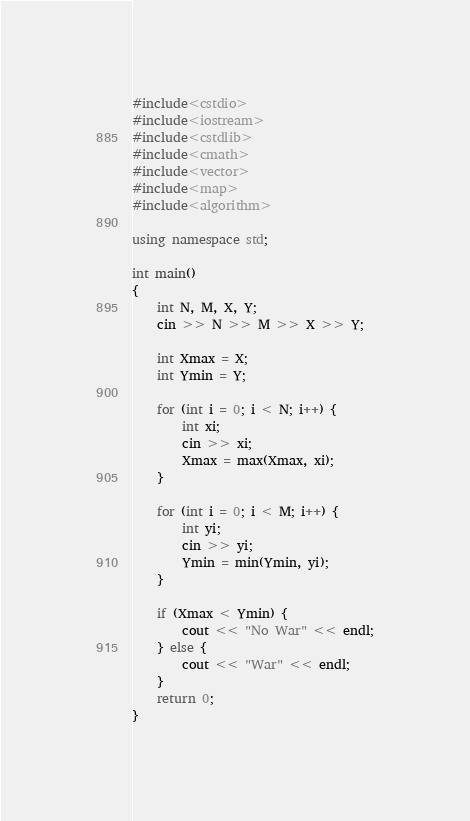Convert code to text. <code><loc_0><loc_0><loc_500><loc_500><_C++_>#include<cstdio>
#include<iostream>
#include<cstdlib>
#include<cmath>
#include<vector>
#include<map>
#include<algorithm>

using namespace std;

int main()
{
    int N, M, X, Y;
    cin >> N >> M >> X >> Y;

    int Xmax = X;
    int Ymin = Y;

    for (int i = 0; i < N; i++) {
        int xi;
        cin >> xi;
        Xmax = max(Xmax, xi);
    }

    for (int i = 0; i < M; i++) {
        int yi;
        cin >> yi;
        Ymin = min(Ymin, yi);
    }

    if (Xmax < Ymin) {
        cout << "No War" << endl;
    } else {
        cout << "War" << endl;
    }
    return 0;
}
</code> 